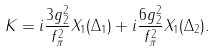Convert formula to latex. <formula><loc_0><loc_0><loc_500><loc_500>K = i \frac { 3 g _ { 2 } ^ { 2 } } { f _ { \pi } ^ { 2 } } X _ { 1 } ( \Delta _ { 1 } ) + i \frac { 6 g _ { 2 } ^ { 2 } } { f _ { \pi } ^ { 2 } } X _ { 1 } ( \Delta _ { 2 } ) .</formula> 